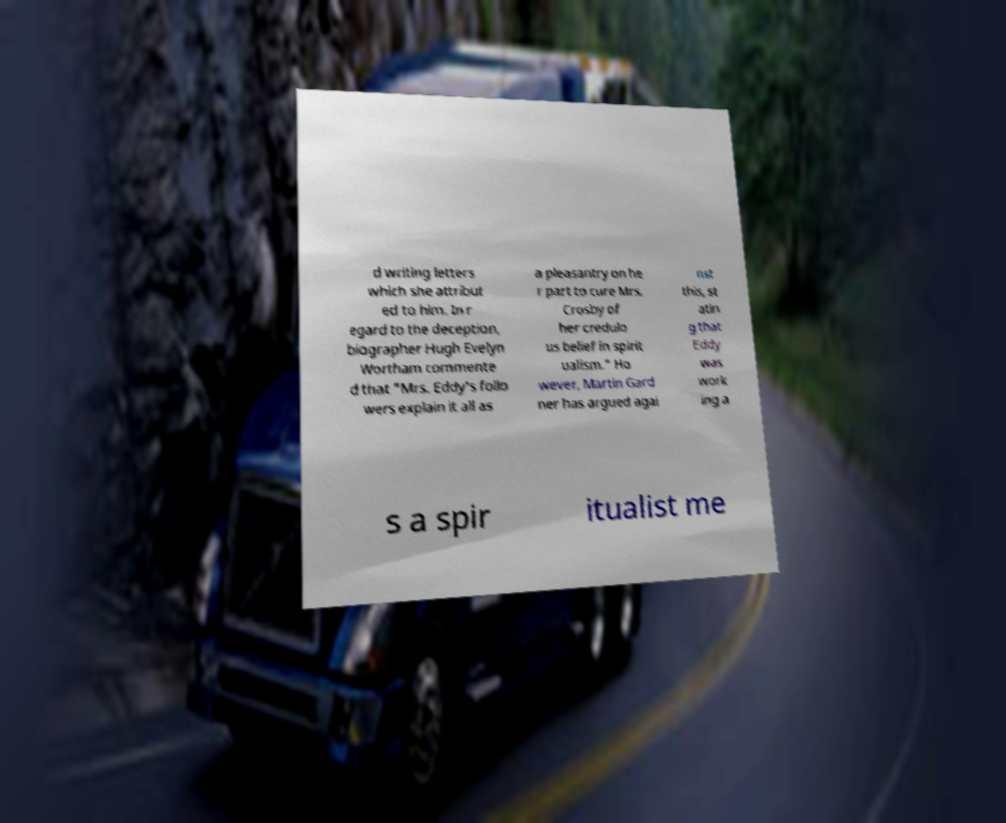For documentation purposes, I need the text within this image transcribed. Could you provide that? d writing letters which she attribut ed to him. In r egard to the deception, biographer Hugh Evelyn Wortham commente d that "Mrs. Eddy's follo wers explain it all as a pleasantry on he r part to cure Mrs. Crosby of her credulo us belief in spirit ualism." Ho wever, Martin Gard ner has argued agai nst this, st atin g that Eddy was work ing a s a spir itualist me 